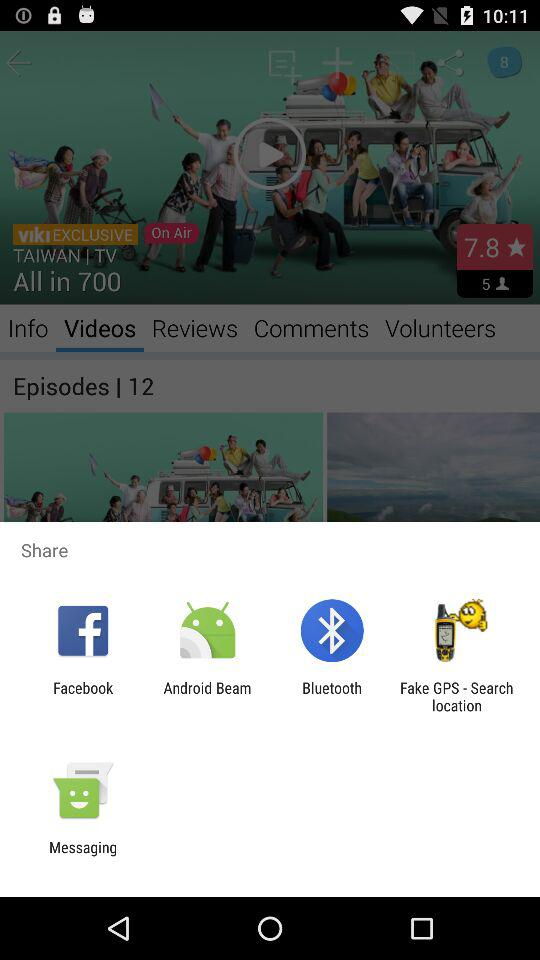What application can I use to share? The applications that you can be used to share are "Facebook", "Android Beam", "Bluetooth", "Fake GPS - Search location" and "Messaging". 